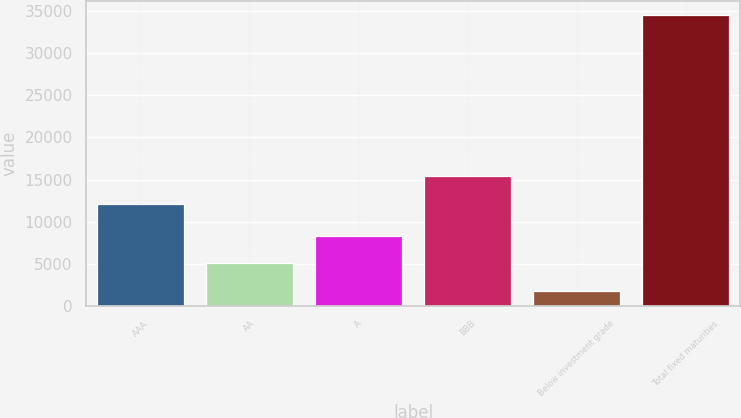<chart> <loc_0><loc_0><loc_500><loc_500><bar_chart><fcel>AAA<fcel>AA<fcel>A<fcel>BBB<fcel>Below investment grade<fcel>Total fixed maturities<nl><fcel>12105<fcel>5080.4<fcel>8348.8<fcel>15373.4<fcel>1812<fcel>34496<nl></chart> 